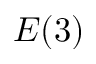<formula> <loc_0><loc_0><loc_500><loc_500>E ( 3 )</formula> 